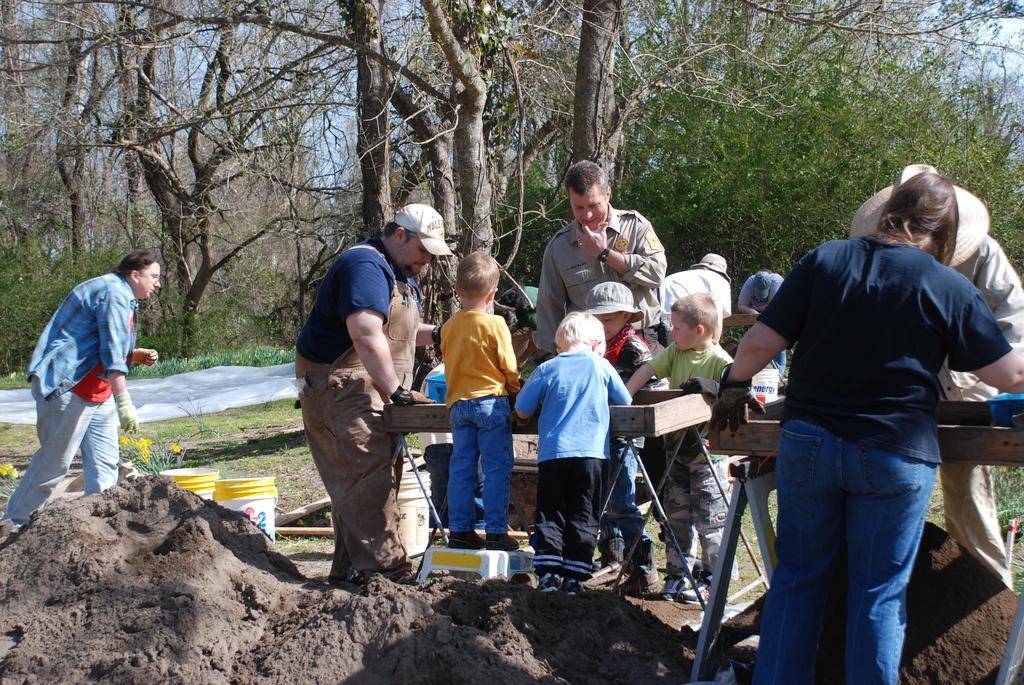Can you describe this image briefly? In this image we can see these people and children are standing on the ground. Here we can see wooden tables on which some objects are kept, here we can see the mud, buckets, flower plants, trees and the sky with clouds in the background. 